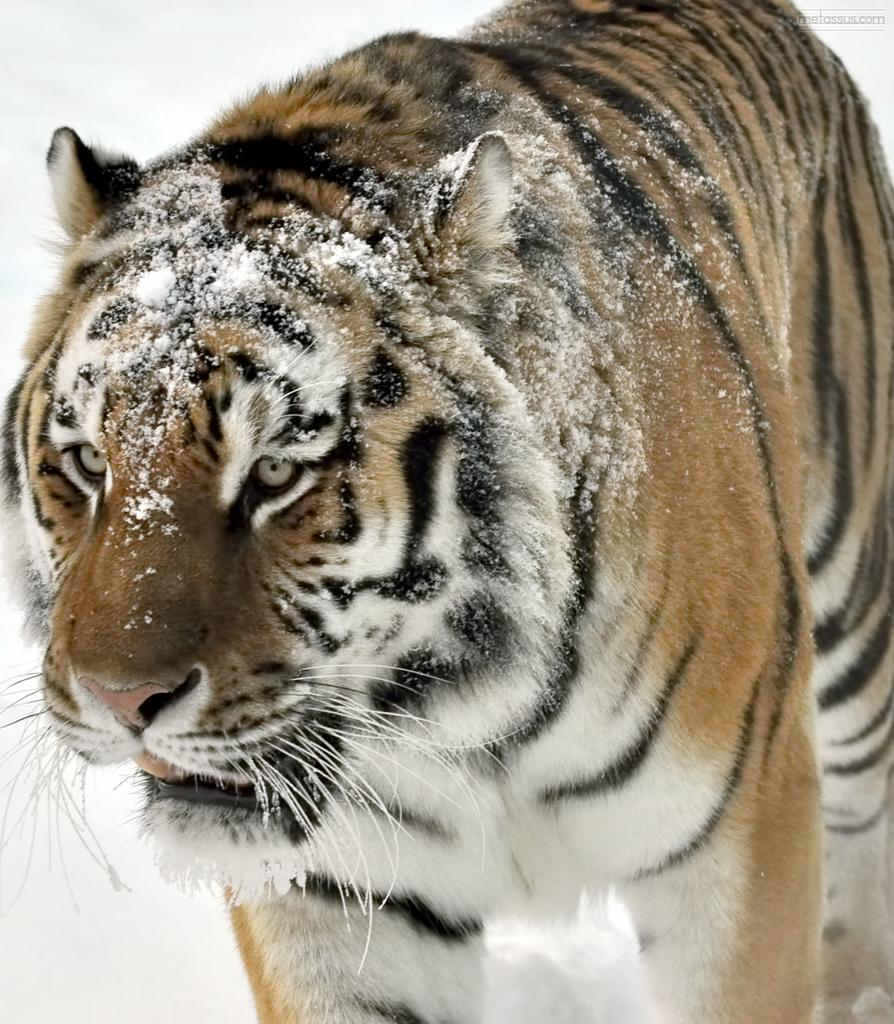What type of animal is in the image? There is a tiger in the image. What is the ground made of in the image? There is snow at the bottom of the image. Where is the text located in the image? The text is in the top right corner of the image. What type of road can be seen in the image? There is no road present in the image; it features a tiger and snow. What musical instrument is being played by the tiger in the image? There is no musical instrument or tiger playing an instrument in the image. 